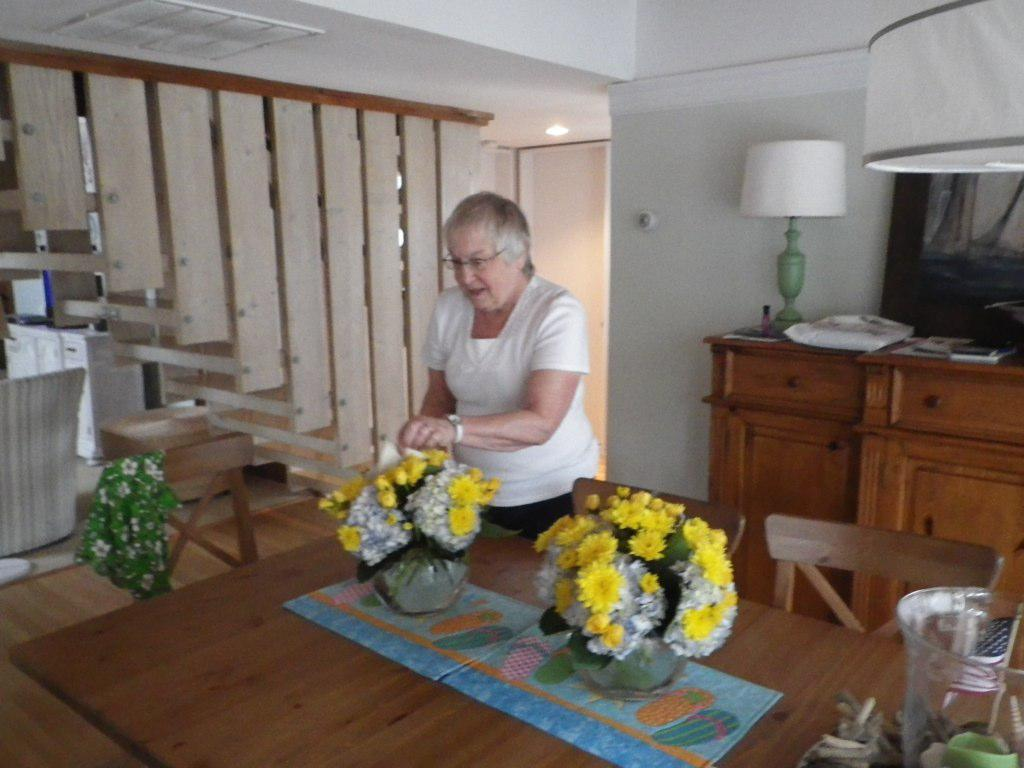What is the main subject of the image? There is a woman standing in the image. What can be seen on the dining table in the image? There are flowers on the dining table. What architectural feature is visible on the right side of the woman? There is a staircase on the right side of the woman. What type of fear can be seen on the woman's face in the image? There is no indication of fear on the woman's face in the image. How many roses are present on the dining table in the image? The provided facts do not specify the type or number of flowers on the dining table, only that there are flowers present. 